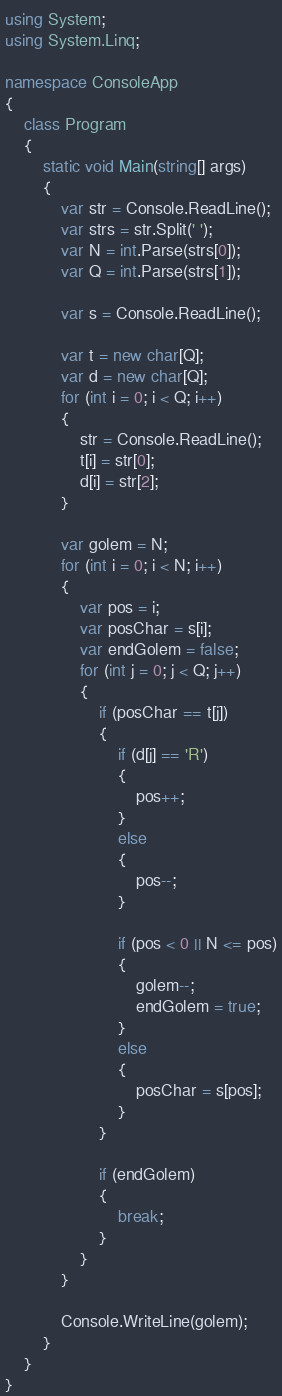<code> <loc_0><loc_0><loc_500><loc_500><_C#_>using System;
using System.Linq;

namespace ConsoleApp
{
    class Program
    {
        static void Main(string[] args)
        {
            var str = Console.ReadLine();
            var strs = str.Split(' ');
            var N = int.Parse(strs[0]);
            var Q = int.Parse(strs[1]);

            var s = Console.ReadLine();

            var t = new char[Q];
            var d = new char[Q];
            for (int i = 0; i < Q; i++)
            {
                str = Console.ReadLine();
                t[i] = str[0];
                d[i] = str[2];
            }

            var golem = N;
            for (int i = 0; i < N; i++)
            {
                var pos = i;
                var posChar = s[i];
                var endGolem = false;
                for (int j = 0; j < Q; j++)
                {
                    if (posChar == t[j])
                    {
                        if (d[j] == 'R')
                        {
                            pos++;
                        }
                        else
                        {
                            pos--;
                        }

                        if (pos < 0 || N <= pos)
                        {
                            golem--;
                            endGolem = true;
                        }
                        else
                        {
                            posChar = s[pos];
                        }
                    }

                    if (endGolem)
                    {
                        break;
                    }
                }
            }

            Console.WriteLine(golem);
        }
    }
}
</code> 